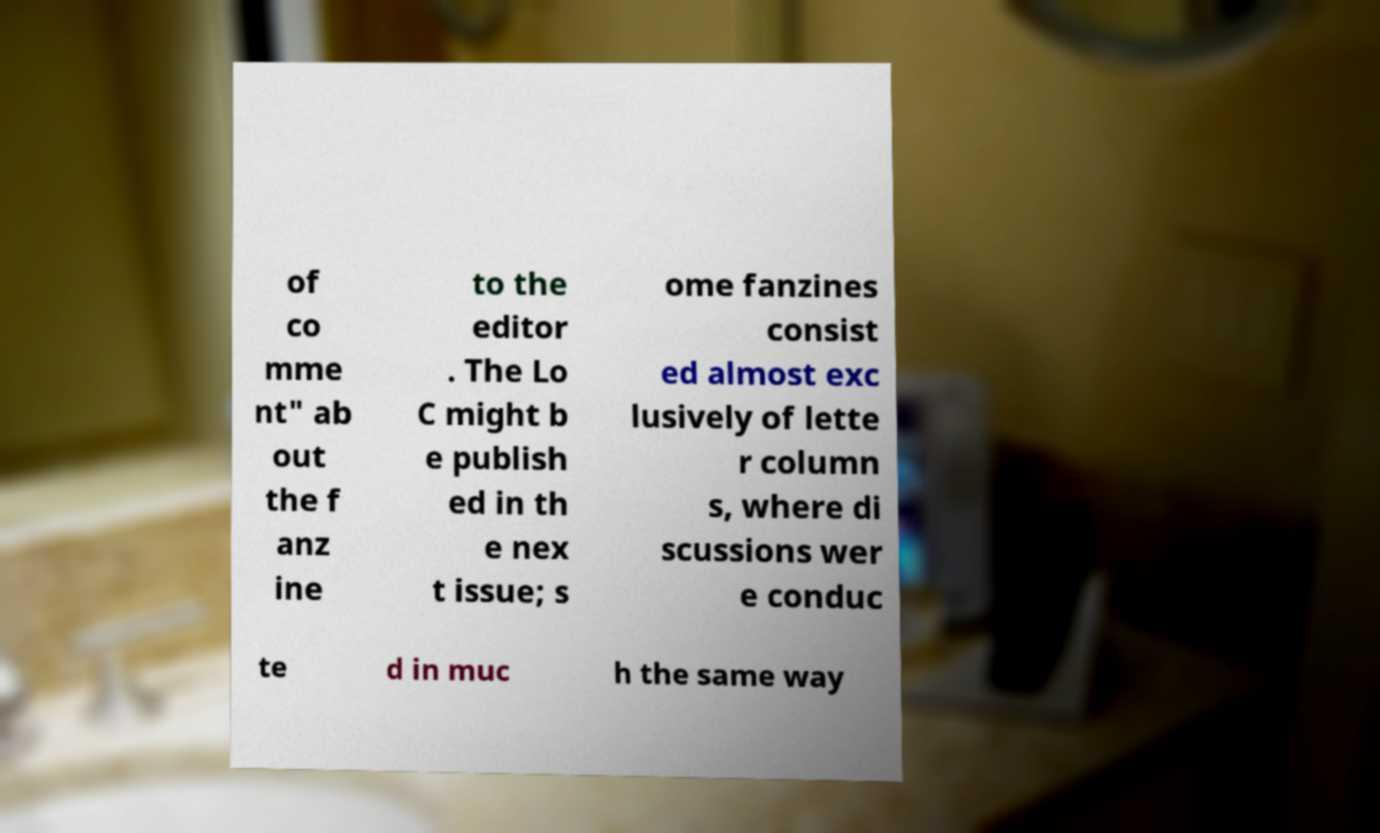Please identify and transcribe the text found in this image. of co mme nt" ab out the f anz ine to the editor . The Lo C might b e publish ed in th e nex t issue; s ome fanzines consist ed almost exc lusively of lette r column s, where di scussions wer e conduc te d in muc h the same way 